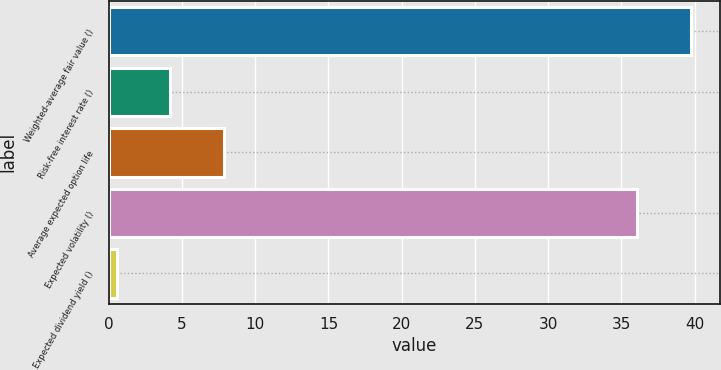Convert chart to OTSL. <chart><loc_0><loc_0><loc_500><loc_500><bar_chart><fcel>Weighted-average fair value ()<fcel>Risk-free interest rate ()<fcel>Average expected option life<fcel>Expected volatility ()<fcel>Expected dividend yield ()<nl><fcel>39.74<fcel>4.21<fcel>7.86<fcel>36.09<fcel>0.56<nl></chart> 